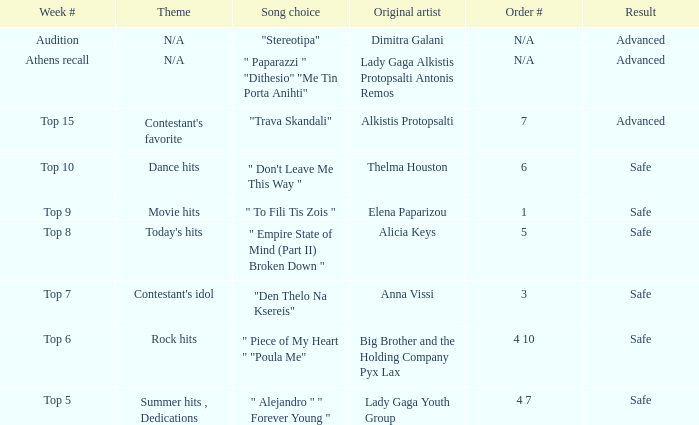Which artists hold sequence number 6? Thelma Houston. 